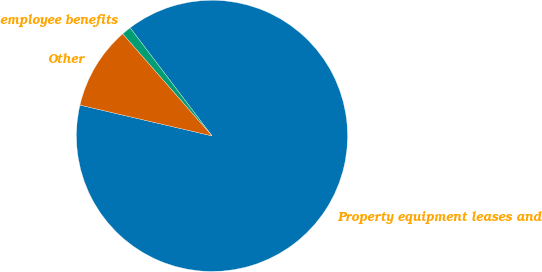Convert chart to OTSL. <chart><loc_0><loc_0><loc_500><loc_500><pie_chart><fcel>Property equipment leases and<fcel>employee benefits<fcel>Other<nl><fcel>88.96%<fcel>1.13%<fcel>9.91%<nl></chart> 